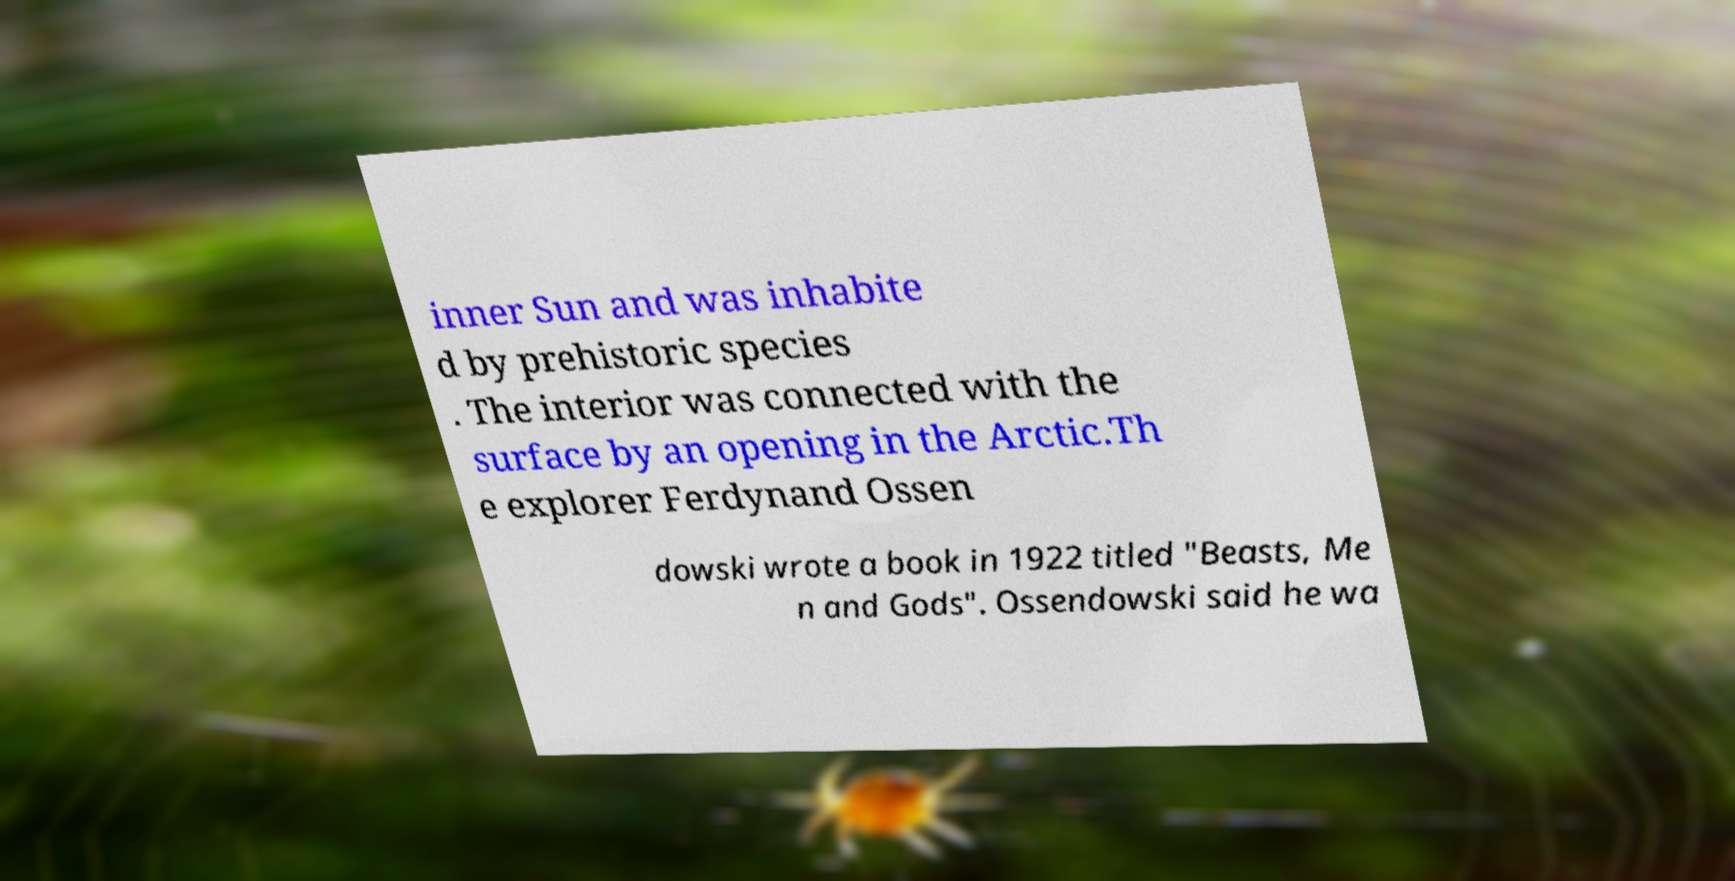Please read and relay the text visible in this image. What does it say? inner Sun and was inhabite d by prehistoric species . The interior was connected with the surface by an opening in the Arctic.Th e explorer Ferdynand Ossen dowski wrote a book in 1922 titled "Beasts, Me n and Gods". Ossendowski said he wa 